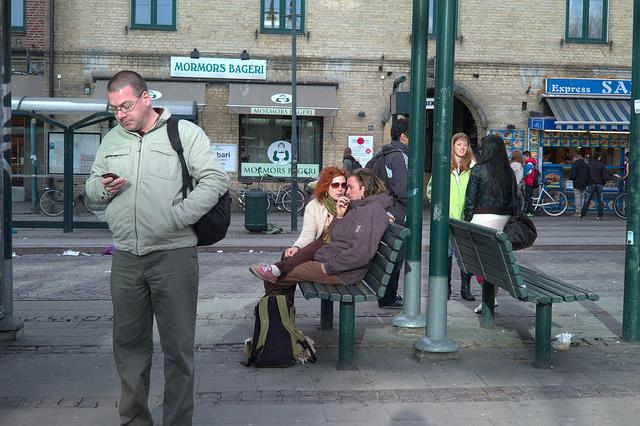What type of shop is the one with the woman's picture in a circle on the window?

Choices:
A) bakery
B) bookstore
C) music shop
D) women's clothing bakery 